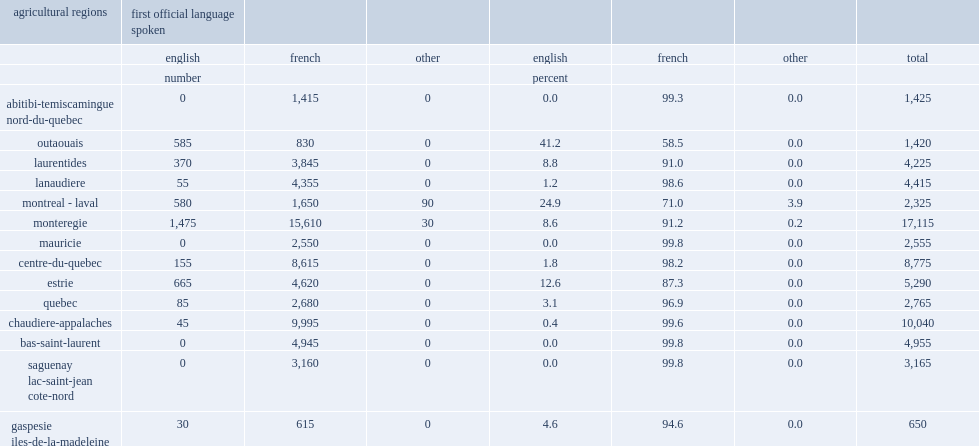What the number of workers aged 15 and over is in quebec's agricultural sector? 69120. What percent of workers aged 15 and over in quebec's agricultural sector were english-language workers? 0.058521. 